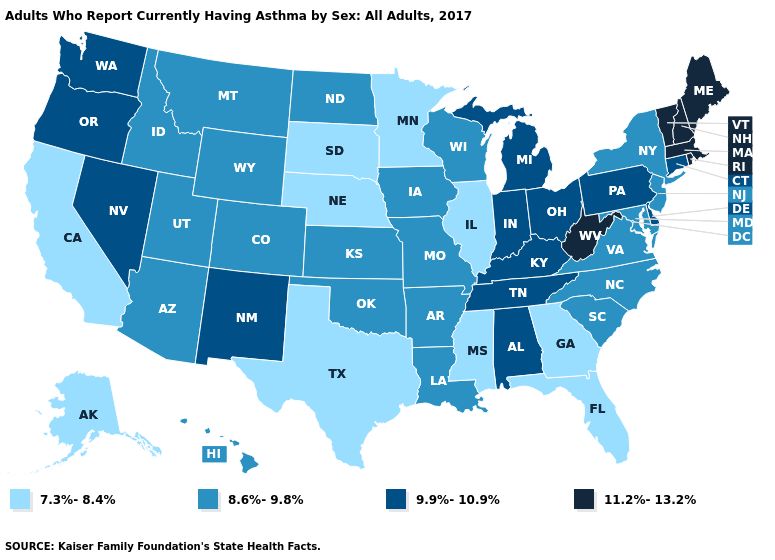Does Louisiana have the same value as North Dakota?
Short answer required. Yes. Name the states that have a value in the range 8.6%-9.8%?
Keep it brief. Arizona, Arkansas, Colorado, Hawaii, Idaho, Iowa, Kansas, Louisiana, Maryland, Missouri, Montana, New Jersey, New York, North Carolina, North Dakota, Oklahoma, South Carolina, Utah, Virginia, Wisconsin, Wyoming. What is the value of Indiana?
Give a very brief answer. 9.9%-10.9%. Which states have the lowest value in the USA?
Answer briefly. Alaska, California, Florida, Georgia, Illinois, Minnesota, Mississippi, Nebraska, South Dakota, Texas. Does West Virginia have the highest value in the USA?
Write a very short answer. Yes. What is the lowest value in the MidWest?
Keep it brief. 7.3%-8.4%. Does Pennsylvania have a higher value than Wyoming?
Give a very brief answer. Yes. Name the states that have a value in the range 9.9%-10.9%?
Answer briefly. Alabama, Connecticut, Delaware, Indiana, Kentucky, Michigan, Nevada, New Mexico, Ohio, Oregon, Pennsylvania, Tennessee, Washington. What is the value of Massachusetts?
Quick response, please. 11.2%-13.2%. Which states have the lowest value in the South?
Concise answer only. Florida, Georgia, Mississippi, Texas. Name the states that have a value in the range 7.3%-8.4%?
Be succinct. Alaska, California, Florida, Georgia, Illinois, Minnesota, Mississippi, Nebraska, South Dakota, Texas. What is the lowest value in states that border Connecticut?
Quick response, please. 8.6%-9.8%. What is the value of Maryland?
Short answer required. 8.6%-9.8%. What is the highest value in states that border Oklahoma?
Be succinct. 9.9%-10.9%. What is the value of Missouri?
Answer briefly. 8.6%-9.8%. 